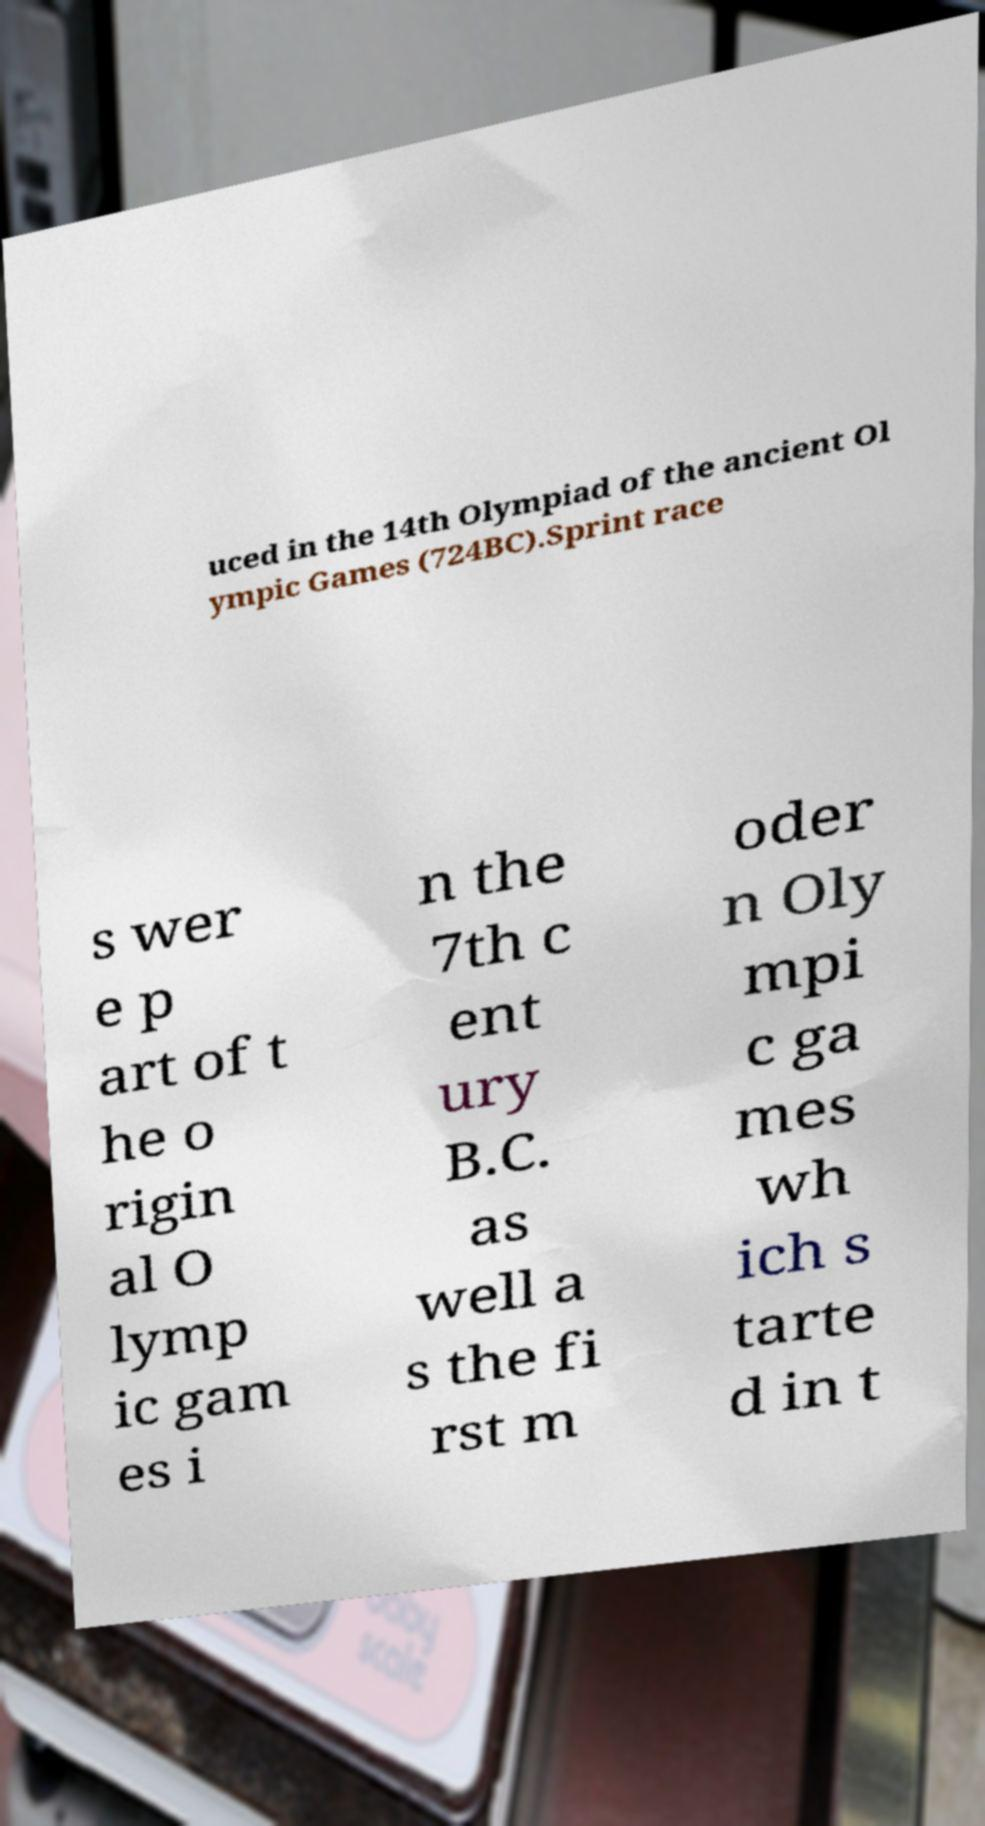What messages or text are displayed in this image? I need them in a readable, typed format. uced in the 14th Olympiad of the ancient Ol ympic Games (724BC).Sprint race s wer e p art of t he o rigin al O lymp ic gam es i n the 7th c ent ury B.C. as well a s the fi rst m oder n Oly mpi c ga mes wh ich s tarte d in t 